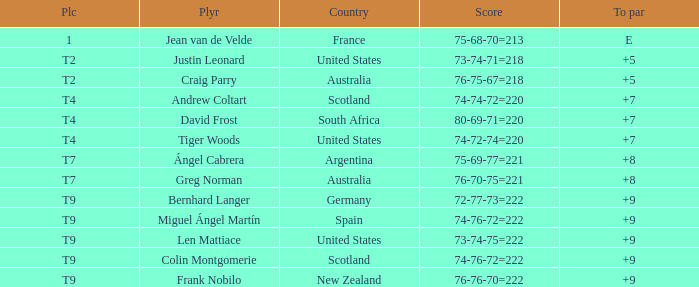Which player from the United States is in a place of T2? Justin Leonard. 